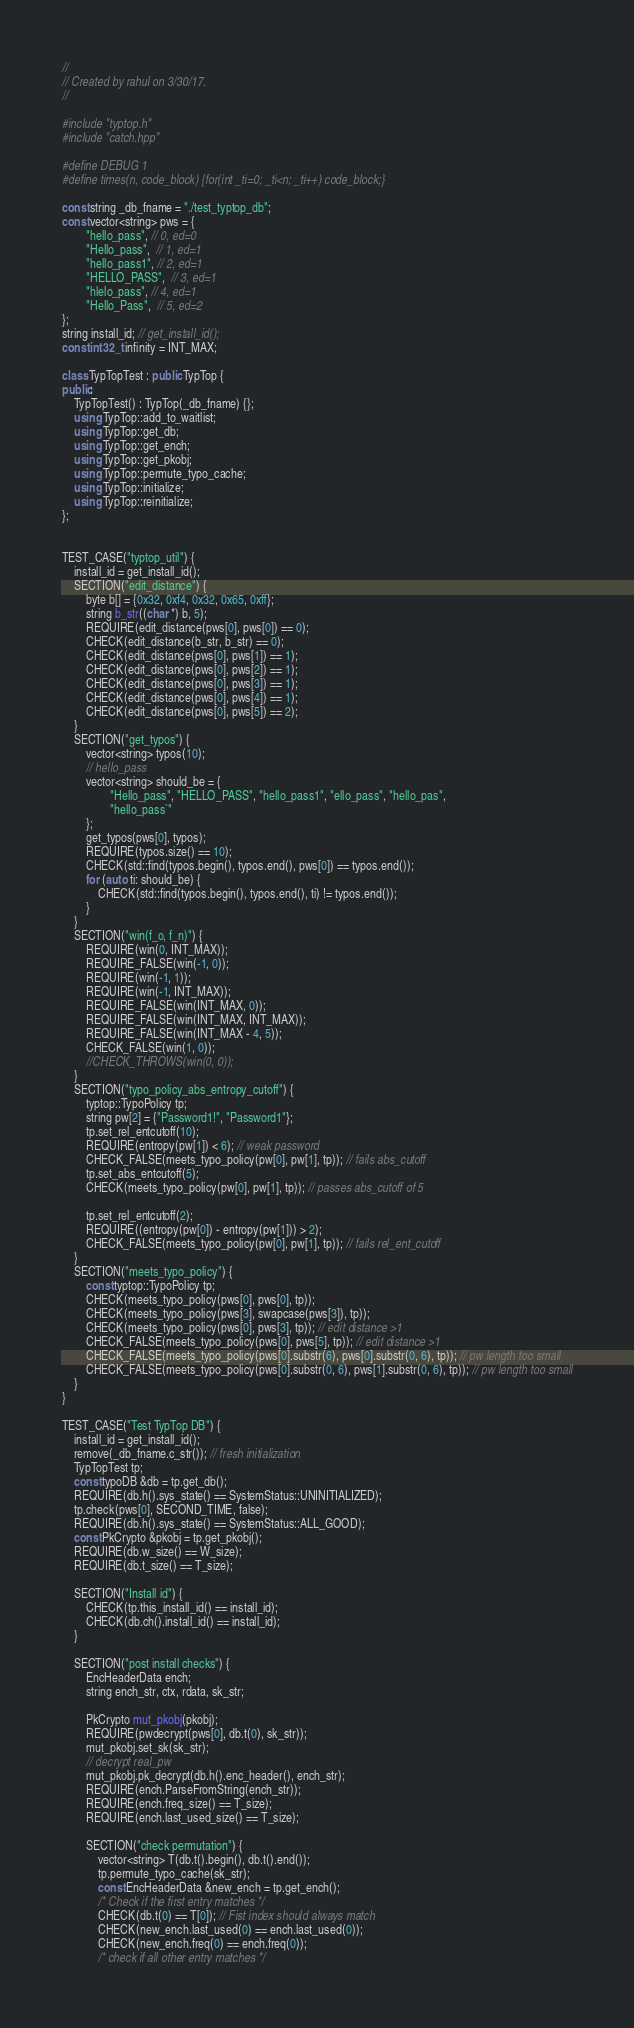<code> <loc_0><loc_0><loc_500><loc_500><_C++_>//
// Created by rahul on 3/30/17.
//

#include "typtop.h"
#include "catch.hpp"

#define DEBUG 1
#define times(n, code_block) {for(int _ti=0; _ti<n; _ti++) code_block;}

const string _db_fname = "./test_typtop_db";
const vector<string> pws = {
        "hello_pass", // 0, ed=0
        "Hello_pass",  // 1, ed=1
        "hello_pass1", // 2, ed=1
        "HELLO_PASS",  // 3, ed=1
        "hlelo_pass", // 4, ed=1
        "Hello_Pass",  // 5, ed=2
};
string install_id; // get_install_id();
const int32_t infinity = INT_MAX;

class TypTopTest : public TypTop {
public:
    TypTopTest() : TypTop(_db_fname) {};
    using TypTop::add_to_waitlist;
    using TypTop::get_db;
    using TypTop::get_ench;
    using TypTop::get_pkobj;
    using TypTop::permute_typo_cache;
    using TypTop::initialize;
    using TypTop::reinitialize;
};


TEST_CASE("typtop_util") {
    install_id = get_install_id();
    SECTION("edit_distance") {
        byte b[] = {0x32, 0xf4, 0x32, 0x65, 0xff};
        string b_str((char *) b, 5);
        REQUIRE(edit_distance(pws[0], pws[0]) == 0);
        CHECK(edit_distance(b_str, b_str) == 0);
        CHECK(edit_distance(pws[0], pws[1]) == 1);
        CHECK(edit_distance(pws[0], pws[2]) == 1);
        CHECK(edit_distance(pws[0], pws[3]) == 1);
        CHECK(edit_distance(pws[0], pws[4]) == 1);
        CHECK(edit_distance(pws[0], pws[5]) == 2);
    }
    SECTION("get_typos") {
        vector<string> typos(10);
        // hello_pass
        vector<string> should_be = {
                "Hello_pass", "HELLO_PASS", "hello_pass1", "ello_pass", "hello_pas",
                "hello_pass`"
        };
        get_typos(pws[0], typos);
        REQUIRE(typos.size() == 10);
        CHECK(std::find(typos.begin(), typos.end(), pws[0]) == typos.end());
        for (auto ti: should_be) {
            CHECK(std::find(typos.begin(), typos.end(), ti) != typos.end());
        }
    }
    SECTION("win(f_o, f_n)") {
        REQUIRE(win(0, INT_MAX));
        REQUIRE_FALSE(win(-1, 0));
        REQUIRE(win(-1, 1));
        REQUIRE(win(-1, INT_MAX));
        REQUIRE_FALSE(win(INT_MAX, 0));
        REQUIRE_FALSE(win(INT_MAX, INT_MAX));
        REQUIRE_FALSE(win(INT_MAX - 4, 5));
        CHECK_FALSE(win(1, 0));
        //CHECK_THROWS(win(0, 0));
    }
    SECTION("typo_policy_abs_entropy_cutoff") {
        typtop::TypoPolicy tp;
        string pw[2] = {"Password1!", "Password1"};
        tp.set_rel_entcutoff(10);
        REQUIRE(entropy(pw[1]) < 6); // weak password
        CHECK_FALSE(meets_typo_policy(pw[0], pw[1], tp)); // fails abs_cutoff
        tp.set_abs_entcutoff(5);
        CHECK(meets_typo_policy(pw[0], pw[1], tp)); // passes abs_cutoff of 5

        tp.set_rel_entcutoff(2);
        REQUIRE((entropy(pw[0]) - entropy(pw[1])) > 2);
        CHECK_FALSE(meets_typo_policy(pw[0], pw[1], tp)); // fails rel_ent_cutoff
    }
    SECTION("meets_typo_policy") {
        const typtop::TypoPolicy tp;
        CHECK(meets_typo_policy(pws[0], pws[0], tp));
        CHECK(meets_typo_policy(pws[3], swapcase(pws[3]), tp));
        CHECK(meets_typo_policy(pws[0], pws[3], tp)); // edit distance >1
        CHECK_FALSE(meets_typo_policy(pws[0], pws[5], tp)); // edit distance >1
        CHECK_FALSE(meets_typo_policy(pws[0].substr(6), pws[0].substr(0, 6), tp)); // pw length too small
        CHECK_FALSE(meets_typo_policy(pws[0].substr(0, 6), pws[1].substr(0, 6), tp)); // pw length too small
    }
}

TEST_CASE("Test TypTop DB") {
    install_id = get_install_id();
    remove(_db_fname.c_str()); // fresh initialization
    TypTopTest tp;
    const typoDB &db = tp.get_db();
    REQUIRE(db.h().sys_state() == SystemStatus::UNINITIALIZED);
    tp.check(pws[0], SECOND_TIME, false);
    REQUIRE(db.h().sys_state() == SystemStatus::ALL_GOOD);
    const PkCrypto &pkobj = tp.get_pkobj();
    REQUIRE(db.w_size() == W_size);
    REQUIRE(db.t_size() == T_size);

    SECTION("Install id") {
        CHECK(tp.this_install_id() == install_id);
        CHECK(db.ch().install_id() == install_id);
    }

    SECTION("post install checks") {
        EncHeaderData ench;
        string ench_str, ctx, rdata, sk_str;

        PkCrypto mut_pkobj(pkobj);
        REQUIRE(pwdecrypt(pws[0], db.t(0), sk_str));
        mut_pkobj.set_sk(sk_str);
        // decrypt real_pw
        mut_pkobj.pk_decrypt(db.h().enc_header(), ench_str);
        REQUIRE(ench.ParseFromString(ench_str));
        REQUIRE(ench.freq_size() == T_size);
        REQUIRE(ench.last_used_size() == T_size);

        SECTION("check permutation") {
            vector<string> T(db.t().begin(), db.t().end());
            tp.permute_typo_cache(sk_str);
            const EncHeaderData &new_ench = tp.get_ench();
            /* Check if the first entry matches */
            CHECK(db.t(0) == T[0]); // Fist index should always match
            CHECK(new_ench.last_used(0) == ench.last_used(0));
            CHECK(new_ench.freq(0) == ench.freq(0));
            /* check if all other entry matches */</code> 